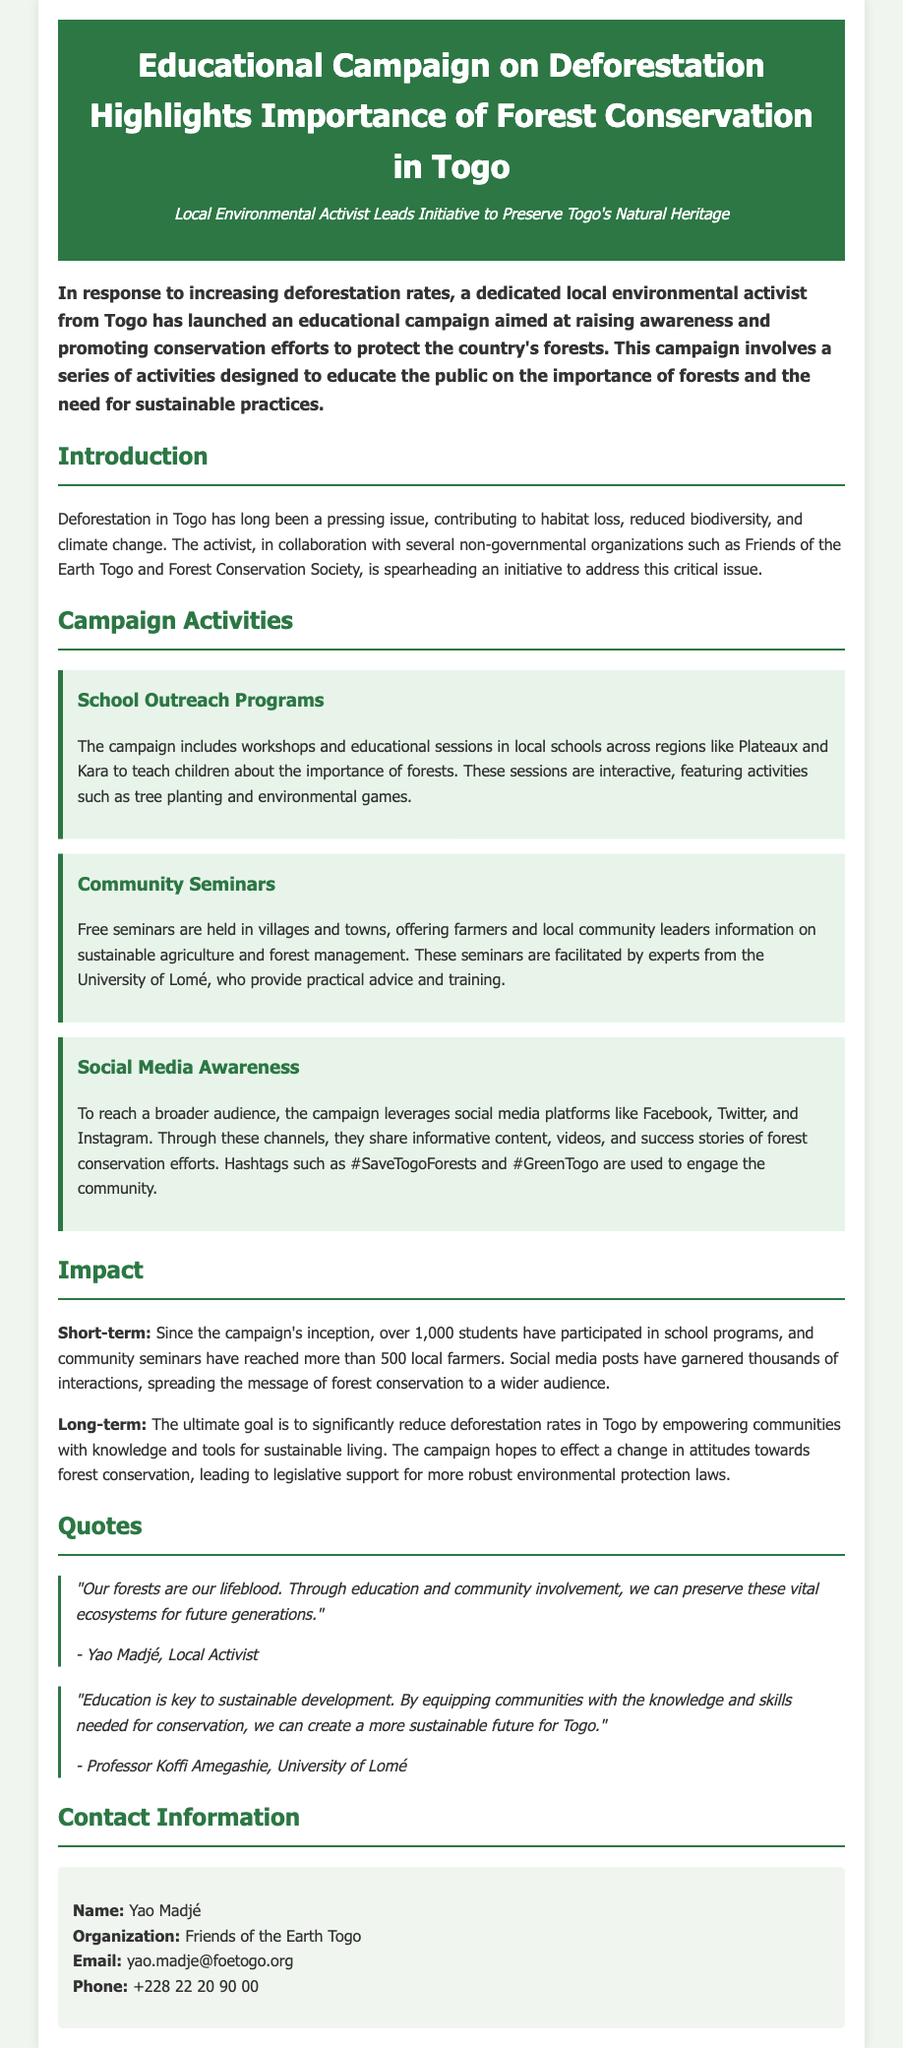What is the title of the campaign? The title of the campaign is mentioned at the top of the document.
Answer: Educational Campaign on Deforestation Highlights Importance of Forest Conservation in Togo Who is the local activist leading the initiative? The name of the local activist is provided in the quotes section of the document.
Answer: Yao Madjé How many students participated in school programs? The document states the number of students who have participated in the school outreach programs.
Answer: 1,000 students What organizations collaborated on the campaign? The document lists organizations involved in the campaign.
Answer: Friends of the Earth Togo and Forest Conservation Society What social media platforms are being used for awareness? The document specifies which social media platforms are leveraged in the campaign.
Answer: Facebook, Twitter, and Instagram What percentage of local farmers attended community seminars? The document mentions the number of farmers reached by the seminars as a specific figure but does not provide a percentage.
Answer: More than 500 local farmers What is the ultimate goal of the campaign? The document states the long-term aim of the campaign related to deforestation rates.
Answer: To significantly reduce deforestation rates in Togo Who provided expertise at the community seminars? The document indicates the expert source facilitating the community seminars.
Answer: Experts from the University of Lomé What is the significance of the quotes? The quotes highlight perspectives on the initiative and underline its importance.
Answer: They emphasize education and community involvement for sustainability 